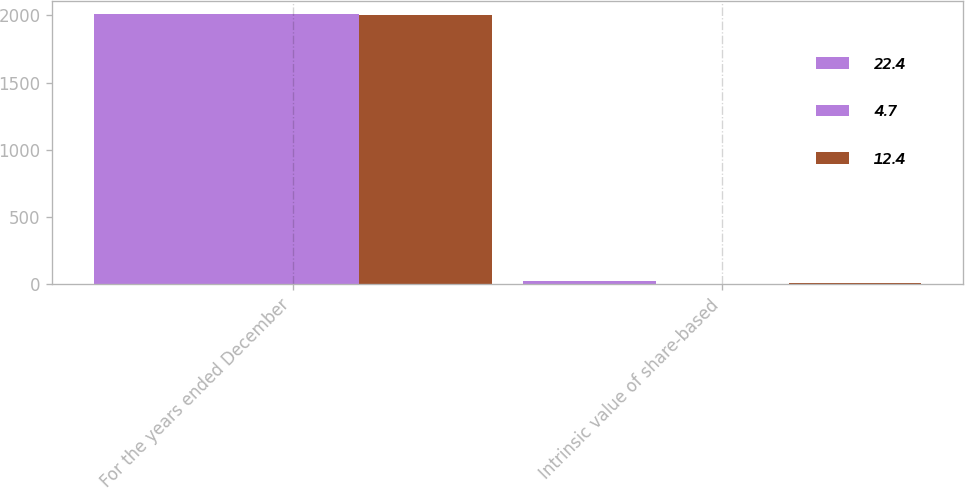Convert chart. <chart><loc_0><loc_0><loc_500><loc_500><stacked_bar_chart><ecel><fcel>For the years ended December<fcel>Intrinsic value of share-based<nl><fcel>22.4<fcel>2007<fcel>22.4<nl><fcel>4.7<fcel>2006<fcel>4.7<nl><fcel>12.4<fcel>2005<fcel>12.4<nl></chart> 